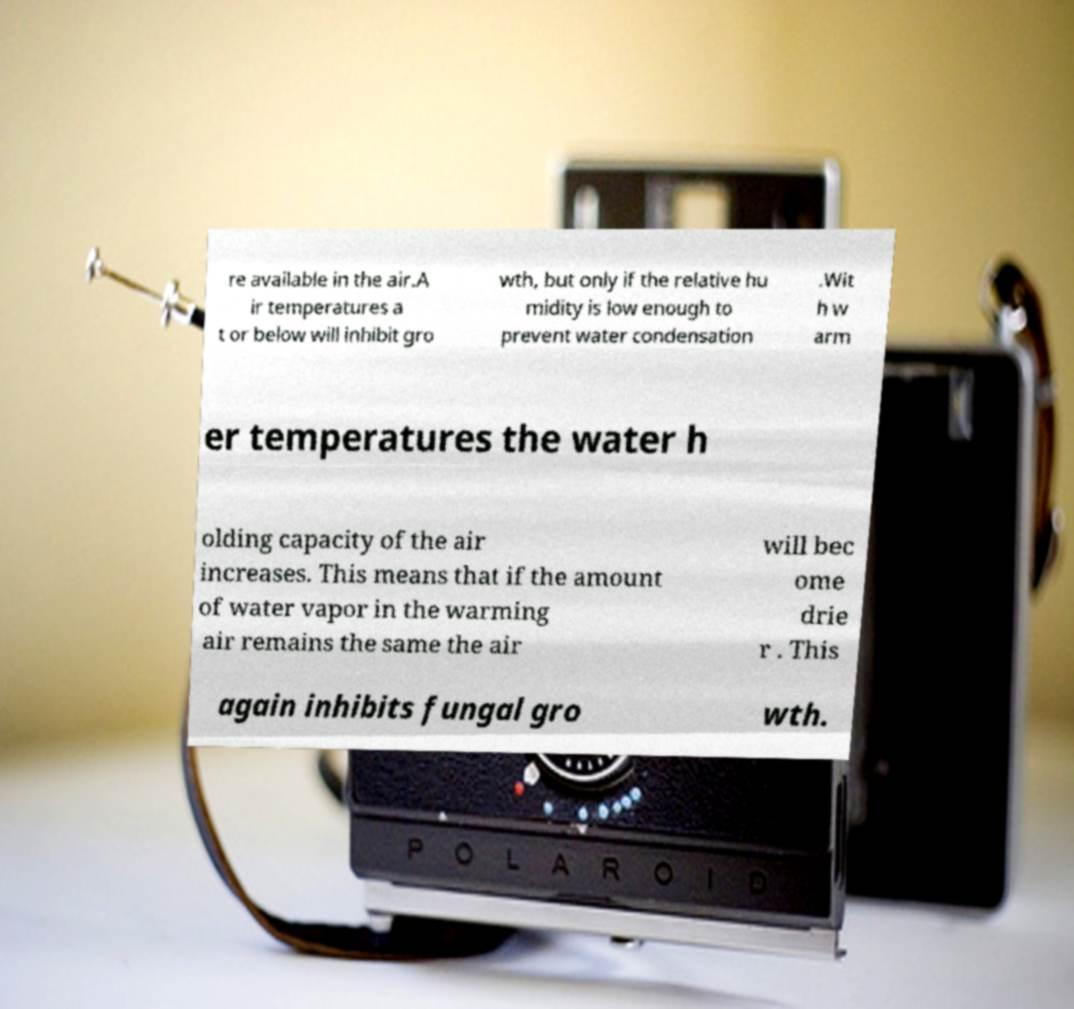Please identify and transcribe the text found in this image. re available in the air.A ir temperatures a t or below will inhibit gro wth, but only if the relative hu midity is low enough to prevent water condensation .Wit h w arm er temperatures the water h olding capacity of the air increases. This means that if the amount of water vapor in the warming air remains the same the air will bec ome drie r . This again inhibits fungal gro wth. 